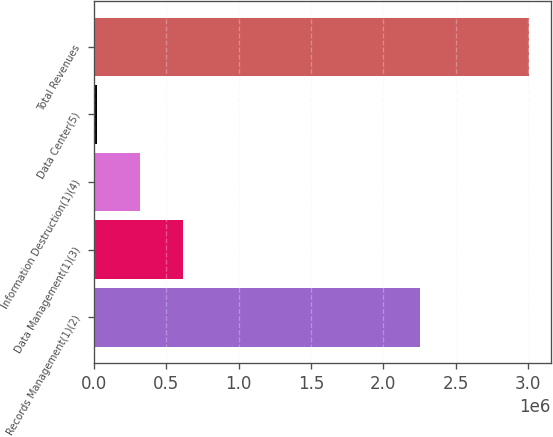Convert chart. <chart><loc_0><loc_0><loc_500><loc_500><bar_chart><fcel>Records Management(1)(2)<fcel>Data Management(1)(3)<fcel>Information Destruction(1)(4)<fcel>Data Center(5)<fcel>Total Revenues<nl><fcel>2.25521e+06<fcel>616847<fcel>317956<fcel>19065<fcel>3.00798e+06<nl></chart> 